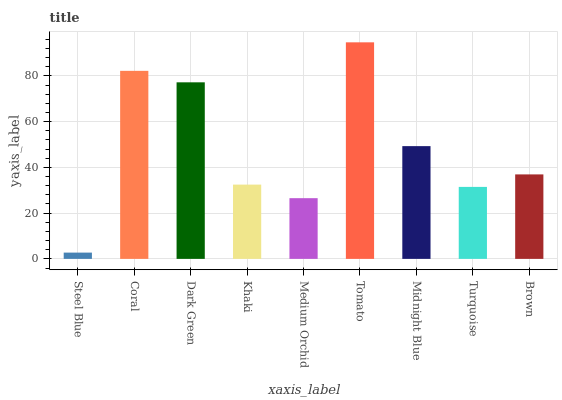Is Steel Blue the minimum?
Answer yes or no. Yes. Is Tomato the maximum?
Answer yes or no. Yes. Is Coral the minimum?
Answer yes or no. No. Is Coral the maximum?
Answer yes or no. No. Is Coral greater than Steel Blue?
Answer yes or no. Yes. Is Steel Blue less than Coral?
Answer yes or no. Yes. Is Steel Blue greater than Coral?
Answer yes or no. No. Is Coral less than Steel Blue?
Answer yes or no. No. Is Brown the high median?
Answer yes or no. Yes. Is Brown the low median?
Answer yes or no. Yes. Is Coral the high median?
Answer yes or no. No. Is Midnight Blue the low median?
Answer yes or no. No. 